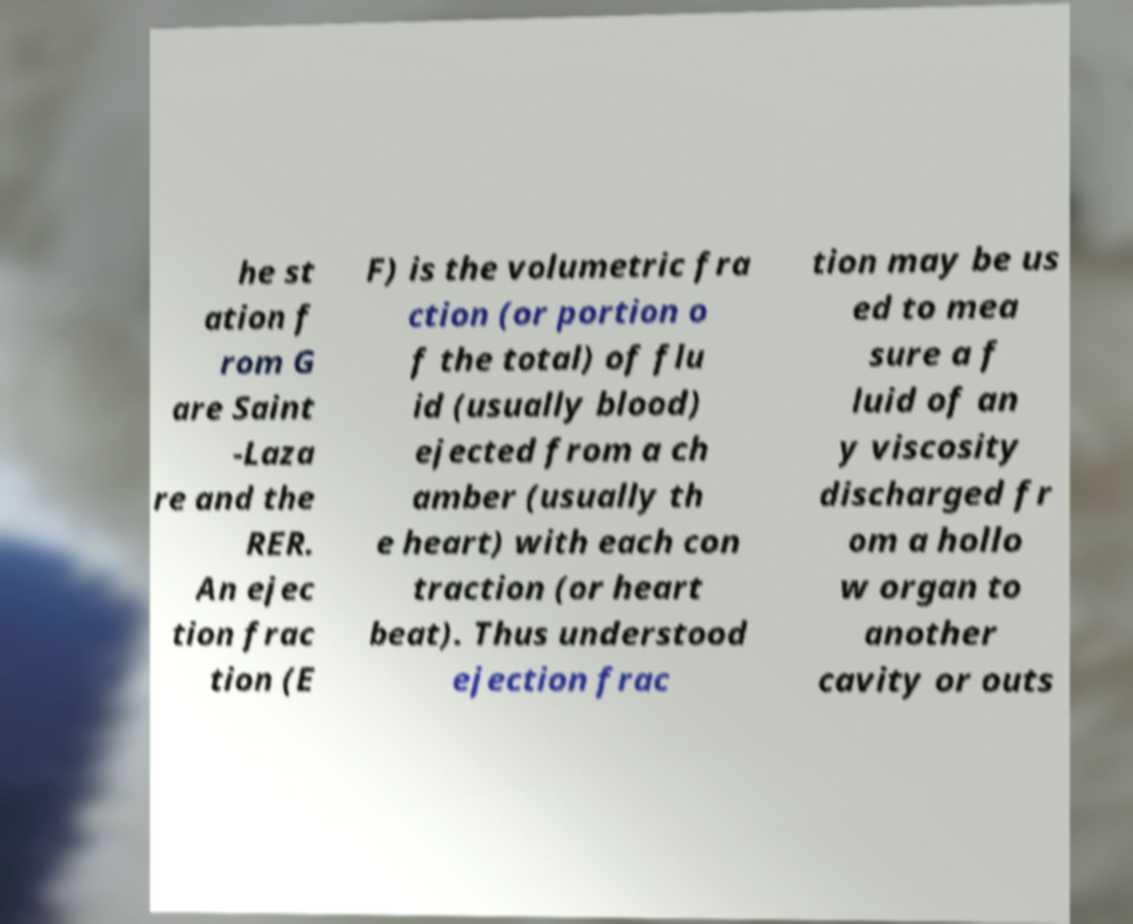Could you assist in decoding the text presented in this image and type it out clearly? he st ation f rom G are Saint -Laza re and the RER. An ejec tion frac tion (E F) is the volumetric fra ction (or portion o f the total) of flu id (usually blood) ejected from a ch amber (usually th e heart) with each con traction (or heart beat). Thus understood ejection frac tion may be us ed to mea sure a f luid of an y viscosity discharged fr om a hollo w organ to another cavity or outs 